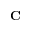<formula> <loc_0><loc_0><loc_500><loc_500>C</formula> 